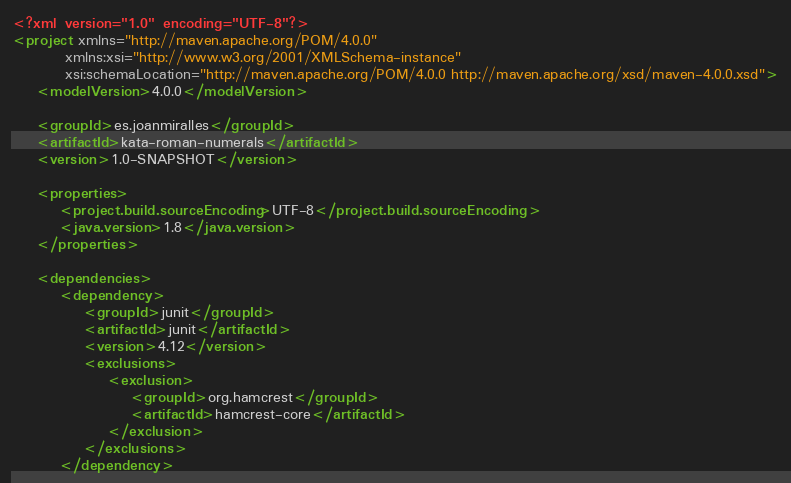Convert code to text. <code><loc_0><loc_0><loc_500><loc_500><_XML_><?xml version="1.0" encoding="UTF-8"?>
<project xmlns="http://maven.apache.org/POM/4.0.0"
         xmlns:xsi="http://www.w3.org/2001/XMLSchema-instance"
         xsi:schemaLocation="http://maven.apache.org/POM/4.0.0 http://maven.apache.org/xsd/maven-4.0.0.xsd">
    <modelVersion>4.0.0</modelVersion>

    <groupId>es.joanmiralles</groupId>
    <artifactId>kata-roman-numerals</artifactId>
    <version>1.0-SNAPSHOT</version>

    <properties>
        <project.build.sourceEncoding>UTF-8</project.build.sourceEncoding>
        <java.version>1.8</java.version>
    </properties>

    <dependencies>
        <dependency>
            <groupId>junit</groupId>
            <artifactId>junit</artifactId>
            <version>4.12</version>
            <exclusions>
                <exclusion>
                    <groupId>org.hamcrest</groupId>
                    <artifactId>hamcrest-core</artifactId>
                </exclusion>
            </exclusions>
        </dependency></code> 